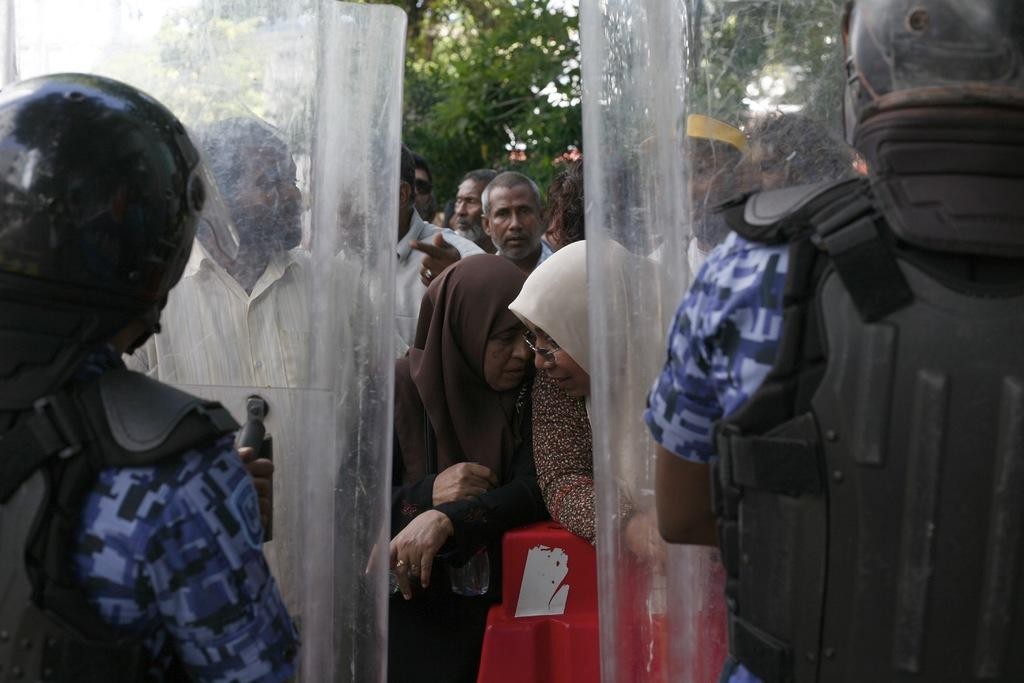What type of clothing are the people wearing in the image? The people are wearing jackets in the image. What additional protective gear are the people wearing? The people are also wearing helmets. Can you describe the background of the image? Trees are present in the background of the image. Are there any other people visible in the image? Yes, there are other people visible in the background of the image. What structures or objects have doors in the image? There are doors visible in the image. What is the annual income of the manager in the image? There is no manager or mention of income in the image. 